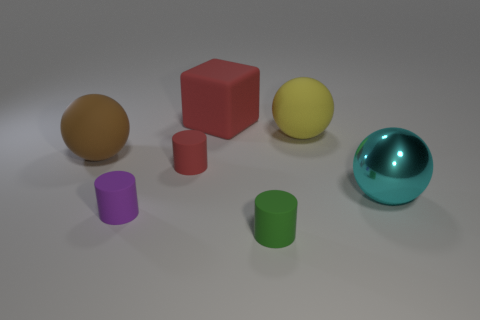Are there any other things that have the same material as the large cyan object?
Offer a very short reply. No. How many green cylinders are made of the same material as the yellow sphere?
Provide a succinct answer. 1. Is the number of big brown balls less than the number of tiny green shiny blocks?
Your response must be concise. No. Do the large sphere left of the big yellow matte object and the tiny green cylinder have the same material?
Your response must be concise. Yes. How many cylinders are purple objects or metal things?
Give a very brief answer. 1. There is a big object that is right of the large red object and behind the large brown matte sphere; what shape is it?
Offer a very short reply. Sphere. What is the color of the tiny rubber object behind the ball that is in front of the big matte object left of the purple object?
Make the answer very short. Red. Is the number of small green matte objects to the right of the large red object less than the number of large yellow things?
Provide a succinct answer. No. Do the red rubber object that is to the left of the large red rubber object and the red object behind the brown rubber thing have the same shape?
Keep it short and to the point. No. How many things are either large things in front of the red rubber cylinder or large cyan shiny balls?
Give a very brief answer. 1. 